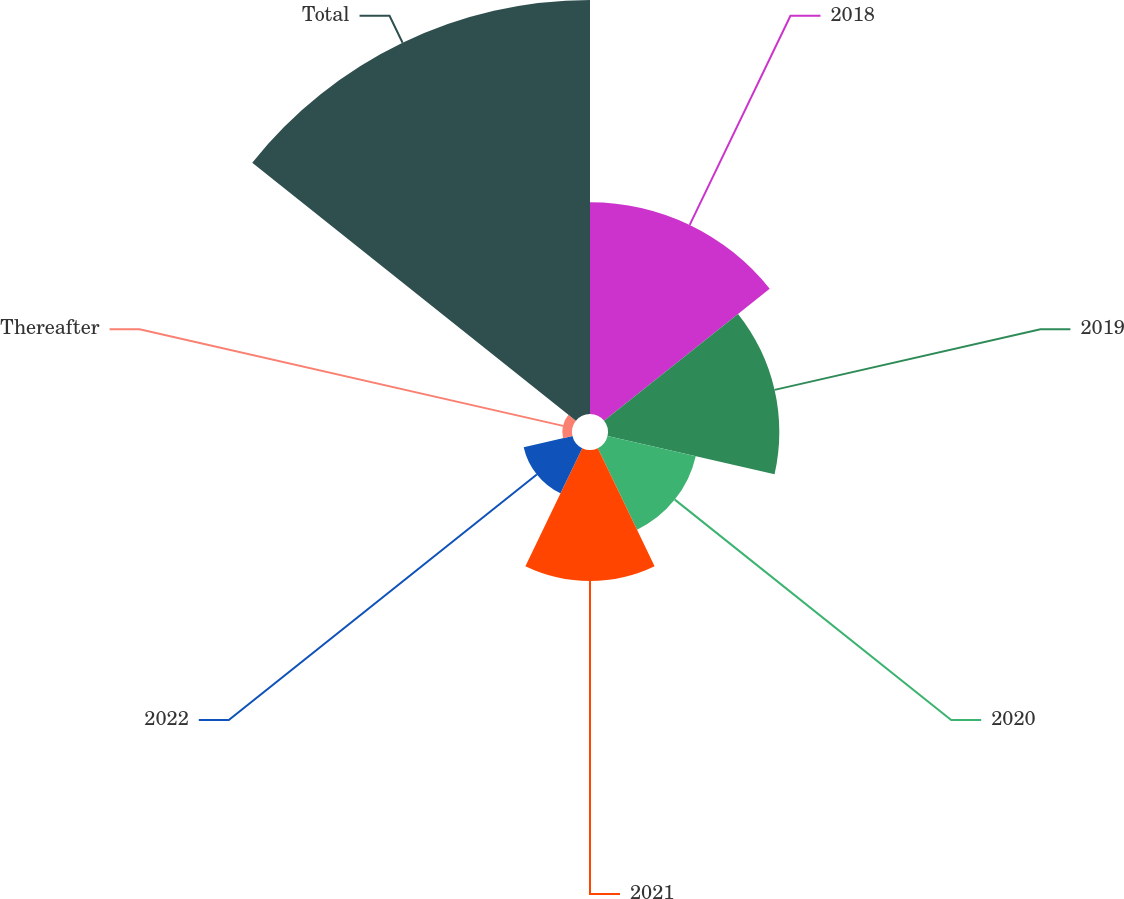Convert chart to OTSL. <chart><loc_0><loc_0><loc_500><loc_500><pie_chart><fcel>2018<fcel>2019<fcel>2020<fcel>2021<fcel>2022<fcel>Thereafter<fcel>Total<nl><fcel>19.65%<fcel>15.89%<fcel>8.39%<fcel>12.14%<fcel>4.64%<fcel>0.89%<fcel>38.4%<nl></chart> 